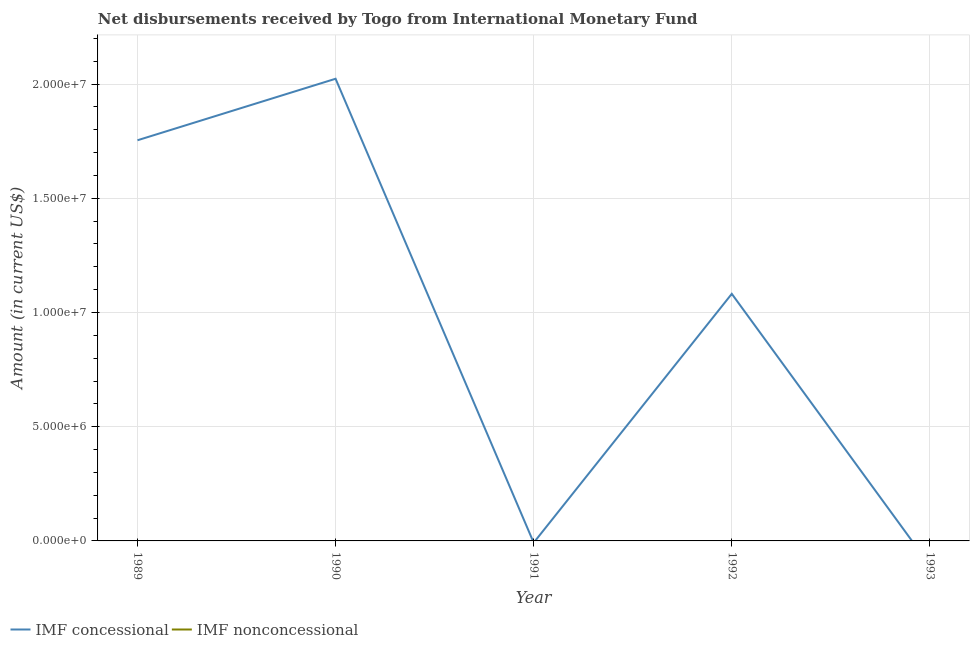Across all years, what is the maximum net concessional disbursements from imf?
Offer a terse response. 2.02e+07. What is the total net concessional disbursements from imf in the graph?
Your answer should be compact. 4.86e+07. What is the difference between the net non concessional disbursements from imf in 1990 and the net concessional disbursements from imf in 1993?
Ensure brevity in your answer.  0. What is the average net concessional disbursements from imf per year?
Give a very brief answer. 9.72e+06. What is the ratio of the net concessional disbursements from imf in 1989 to that in 1990?
Ensure brevity in your answer.  0.87. What is the difference between the highest and the second highest net concessional disbursements from imf?
Give a very brief answer. 2.69e+06. What is the difference between the highest and the lowest net concessional disbursements from imf?
Make the answer very short. 2.02e+07. Does the net non concessional disbursements from imf monotonically increase over the years?
Your answer should be compact. No. Is the net concessional disbursements from imf strictly greater than the net non concessional disbursements from imf over the years?
Provide a succinct answer. Yes. Is the net non concessional disbursements from imf strictly less than the net concessional disbursements from imf over the years?
Your answer should be compact. Yes. How many lines are there?
Offer a very short reply. 1. How many years are there in the graph?
Your response must be concise. 5. How are the legend labels stacked?
Keep it short and to the point. Horizontal. What is the title of the graph?
Offer a terse response. Net disbursements received by Togo from International Monetary Fund. Does "Domestic liabilities" appear as one of the legend labels in the graph?
Ensure brevity in your answer.  No. What is the label or title of the X-axis?
Offer a terse response. Year. What is the label or title of the Y-axis?
Your response must be concise. Amount (in current US$). What is the Amount (in current US$) in IMF concessional in 1989?
Your response must be concise. 1.75e+07. What is the Amount (in current US$) in IMF concessional in 1990?
Ensure brevity in your answer.  2.02e+07. What is the Amount (in current US$) in IMF nonconcessional in 1991?
Ensure brevity in your answer.  0. What is the Amount (in current US$) in IMF concessional in 1992?
Ensure brevity in your answer.  1.08e+07. What is the Amount (in current US$) in IMF nonconcessional in 1992?
Offer a very short reply. 0. Across all years, what is the maximum Amount (in current US$) in IMF concessional?
Offer a terse response. 2.02e+07. Across all years, what is the minimum Amount (in current US$) in IMF concessional?
Offer a very short reply. 0. What is the total Amount (in current US$) of IMF concessional in the graph?
Give a very brief answer. 4.86e+07. What is the total Amount (in current US$) of IMF nonconcessional in the graph?
Give a very brief answer. 0. What is the difference between the Amount (in current US$) of IMF concessional in 1989 and that in 1990?
Your response must be concise. -2.69e+06. What is the difference between the Amount (in current US$) in IMF concessional in 1989 and that in 1992?
Your answer should be very brief. 6.72e+06. What is the difference between the Amount (in current US$) of IMF concessional in 1990 and that in 1992?
Provide a succinct answer. 9.42e+06. What is the average Amount (in current US$) of IMF concessional per year?
Offer a very short reply. 9.72e+06. What is the ratio of the Amount (in current US$) in IMF concessional in 1989 to that in 1990?
Keep it short and to the point. 0.87. What is the ratio of the Amount (in current US$) of IMF concessional in 1989 to that in 1992?
Your response must be concise. 1.62. What is the ratio of the Amount (in current US$) of IMF concessional in 1990 to that in 1992?
Provide a short and direct response. 1.87. What is the difference between the highest and the second highest Amount (in current US$) in IMF concessional?
Your answer should be compact. 2.69e+06. What is the difference between the highest and the lowest Amount (in current US$) of IMF concessional?
Give a very brief answer. 2.02e+07. 